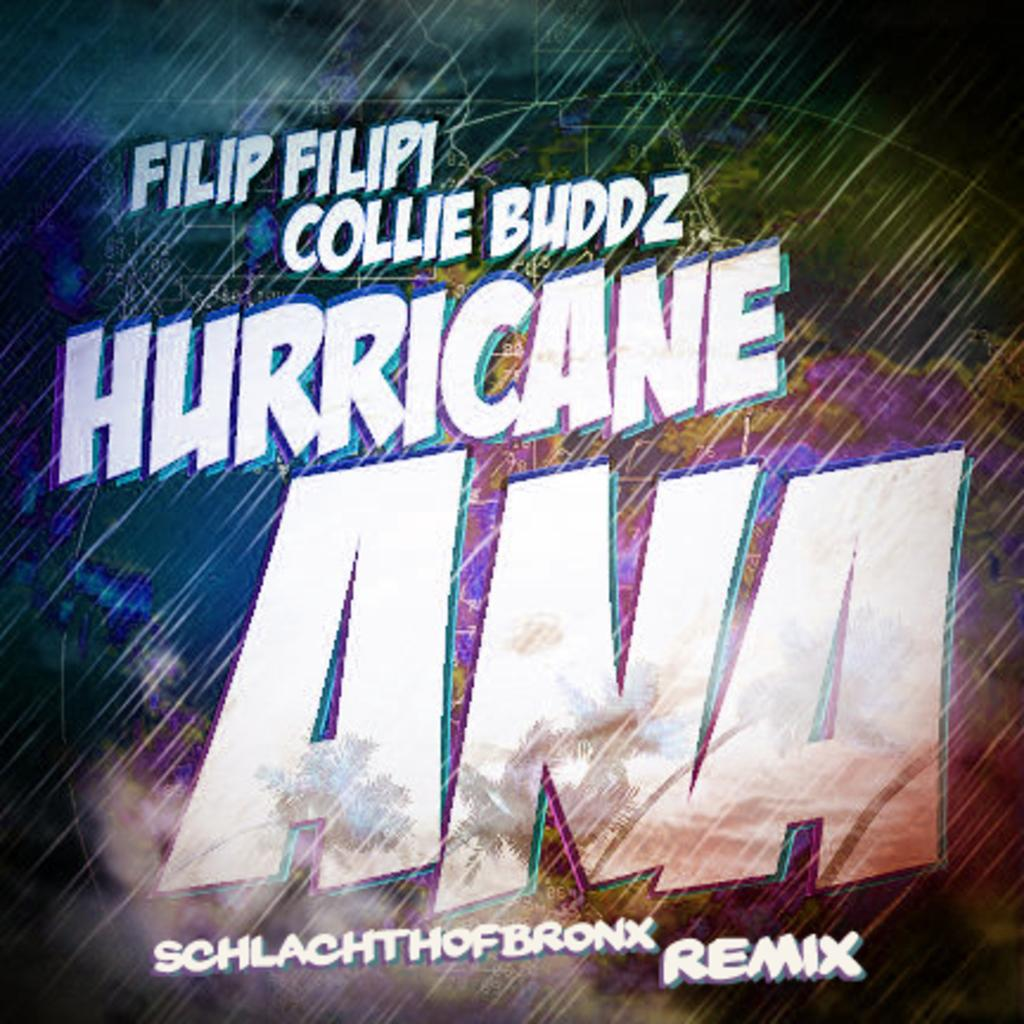<image>
Summarize the visual content of the image. picture with blowing rain and title hurricane ana with filip filipi, collie buddz 